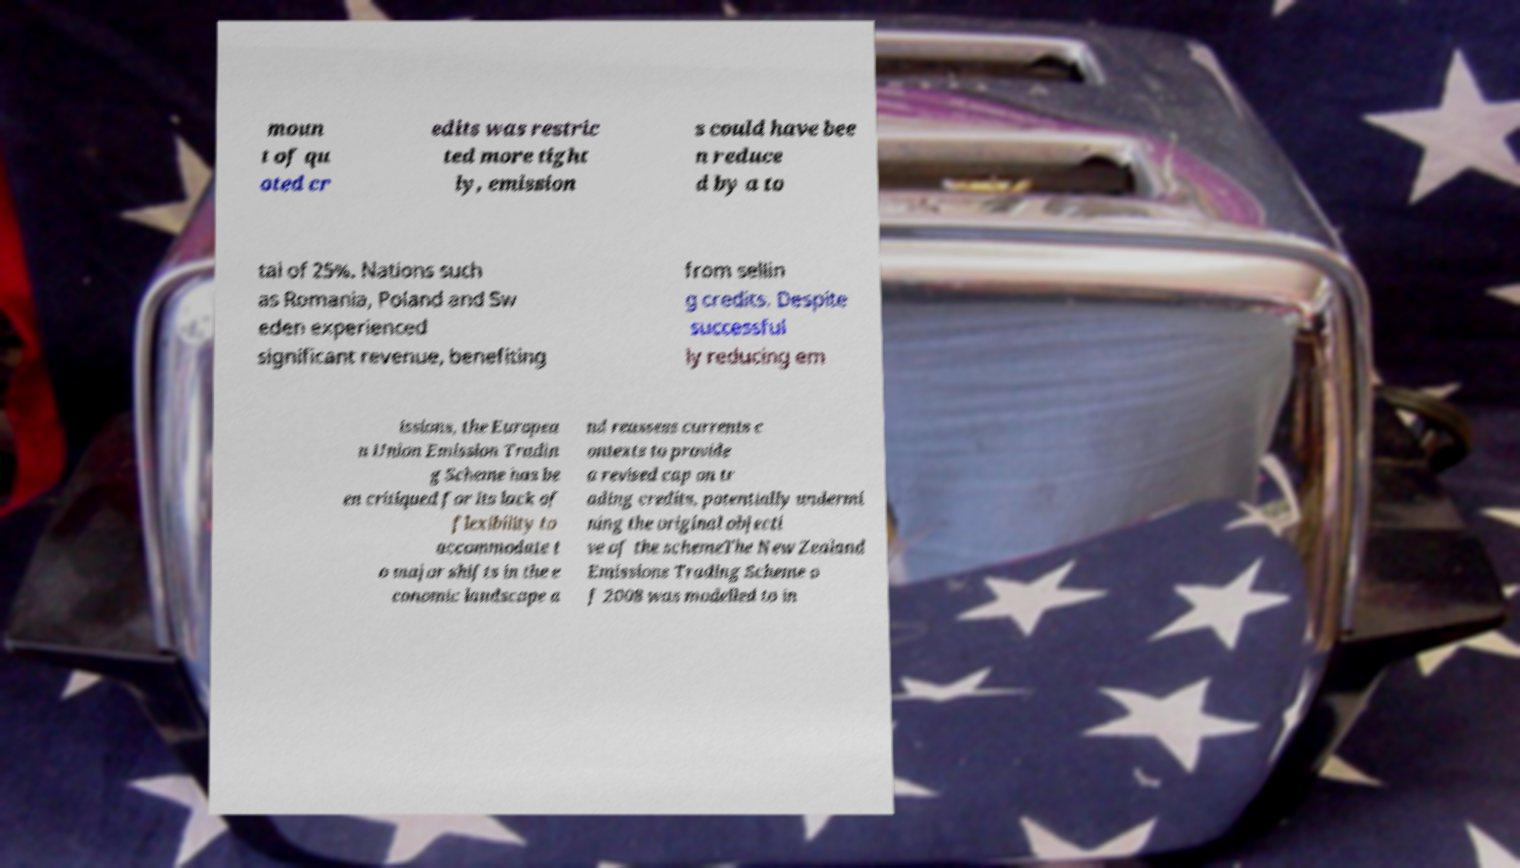Can you accurately transcribe the text from the provided image for me? moun t of qu oted cr edits was restric ted more tight ly, emission s could have bee n reduce d by a to tal of 25%. Nations such as Romania, Poland and Sw eden experienced significant revenue, benefiting from sellin g credits. Despite successful ly reducing em issions, the Europea n Union Emission Tradin g Scheme has be en critiqued for its lack of flexibility to accommodate t o major shifts in the e conomic landscape a nd reassess currents c ontexts to provide a revised cap on tr ading credits, potentially undermi ning the original objecti ve of the schemeThe New Zealand Emissions Trading Scheme o f 2008 was modelled to in 